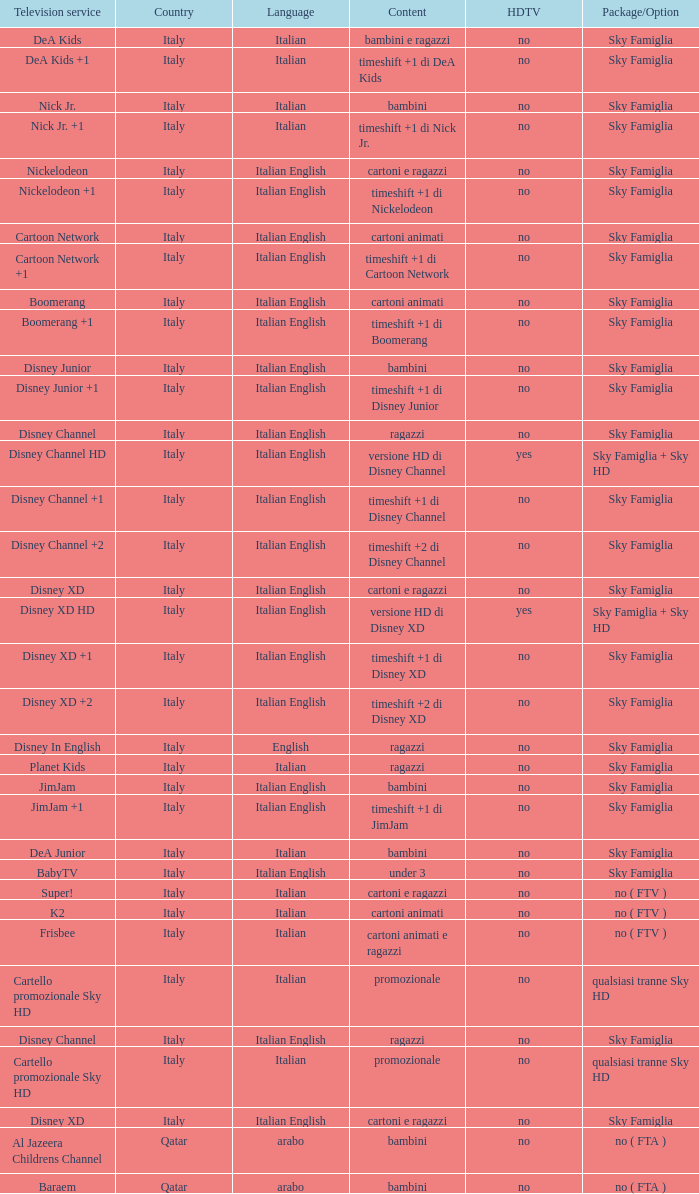With the sky famiglia package/option and boomerang +1 television service, which hdtv is provided? No. 